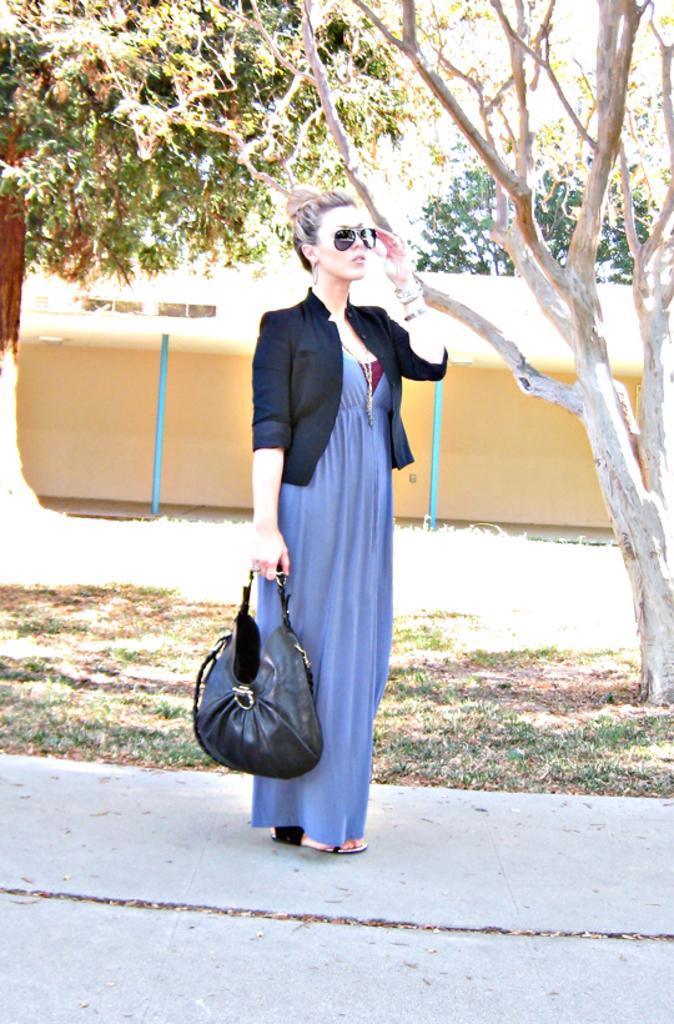Describe this image in one or two sentences. In this image I can see a woman standing and holding a black color bag in her right hand. In the background we can see trees. 